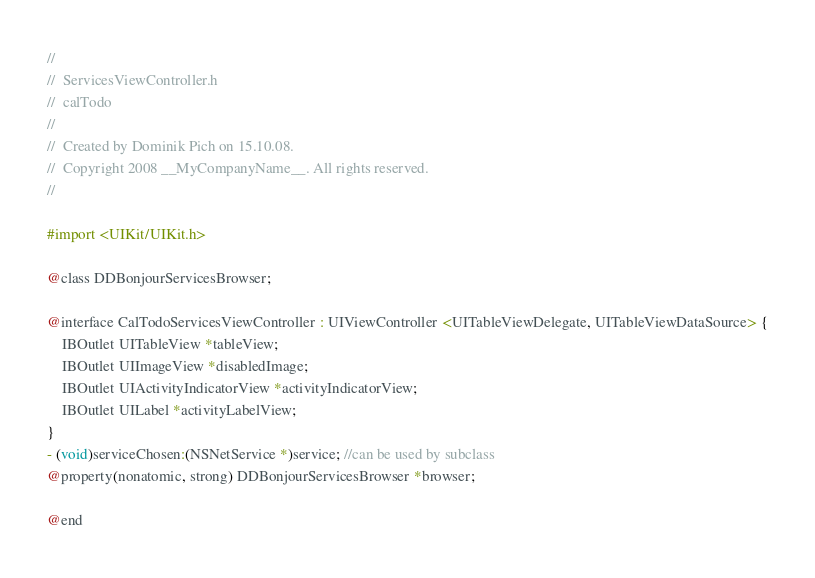<code> <loc_0><loc_0><loc_500><loc_500><_C_>//
//  ServicesViewController.h
//  calTodo
//
//  Created by Dominik Pich on 15.10.08.
//  Copyright 2008 __MyCompanyName__. All rights reserved.
//

#import <UIKit/UIKit.h>

@class DDBonjourServicesBrowser;

@interface CalTodoServicesViewController : UIViewController <UITableViewDelegate, UITableViewDataSource> {
    IBOutlet UITableView *tableView;
	IBOutlet UIImageView *disabledImage;
	IBOutlet UIActivityIndicatorView *activityIndicatorView;
	IBOutlet UILabel *activityLabelView;
}
- (void)serviceChosen:(NSNetService *)service; //can be used by subclass
@property(nonatomic, strong) DDBonjourServicesBrowser *browser;

@end
</code> 